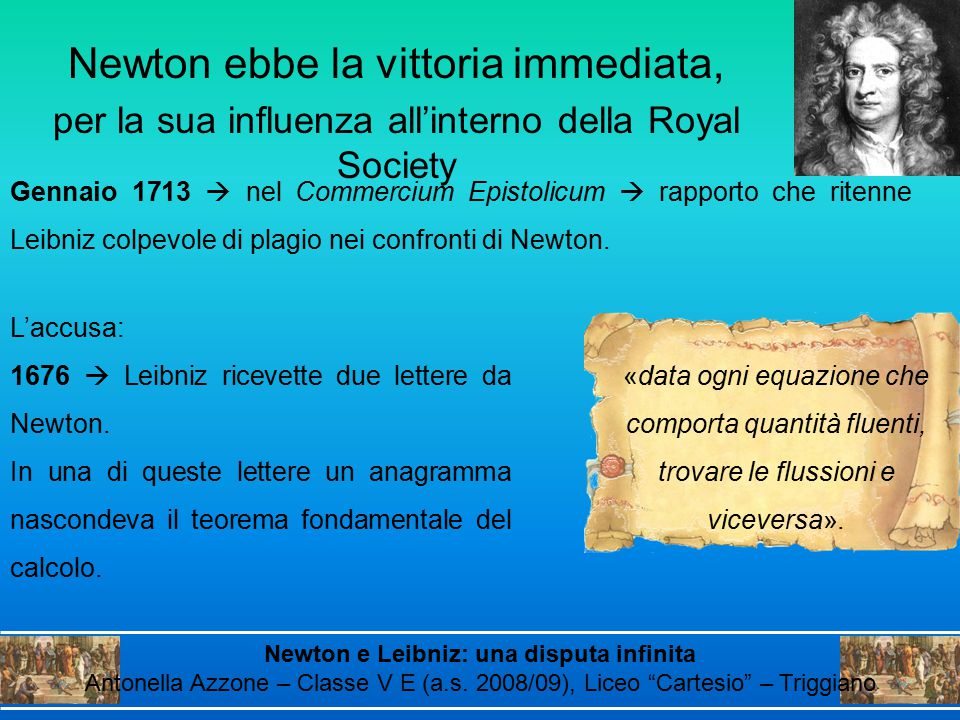Can you describe how the anagram would influence the teaching of calculus in modern classrooms if more widely known? If the historical significance of the anagram sent by Newton to Leibniz were more widely known, it could revolutionize the teaching of calculus in modern classrooms. Educators might use it as a compelling story to illustrate the origins and development of calculus, capturing students' imaginations with tales of intellectual rivalry and cryptic messages. The anagram could be introduced as an engaging puzzle, prompting students to decode it themselves using the knowledge they've gained. This method would not only make learning calculus more interactive but also instill a deeper appreciation for the historical context and the minds behind the mathematical principles. Additionally, it could serve as a lesson in academic integrity and the collaborative nature of scientific discovery, emphasizing the importance of clear communication and proper attribution in advancing knowledge. 